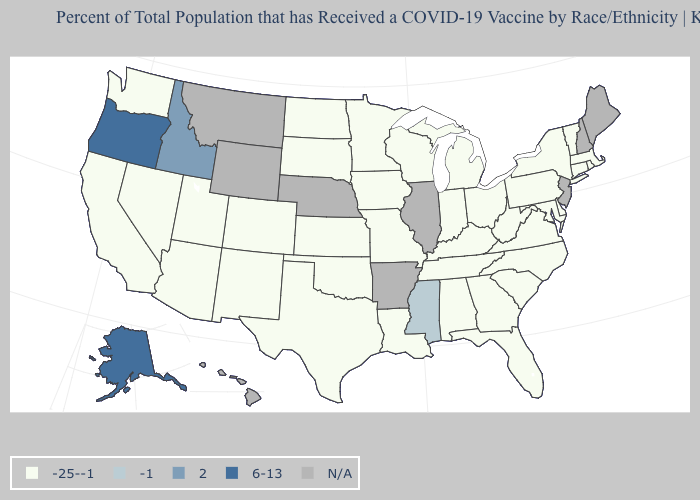Does Alaska have the lowest value in the West?
Keep it brief. No. How many symbols are there in the legend?
Short answer required. 5. What is the value of Nebraska?
Short answer required. N/A. What is the value of Mississippi?
Write a very short answer. -1. Among the states that border Louisiana , does Texas have the highest value?
Short answer required. No. What is the highest value in the USA?
Concise answer only. 6-13. Which states have the highest value in the USA?
Be succinct. Alaska, Oregon. What is the value of Kansas?
Short answer required. -25--1. What is the value of Hawaii?
Keep it brief. N/A. What is the value of Vermont?
Concise answer only. -25--1. Which states hav the highest value in the MidWest?
Quick response, please. Indiana, Iowa, Kansas, Michigan, Minnesota, Missouri, North Dakota, Ohio, South Dakota, Wisconsin. How many symbols are there in the legend?
Give a very brief answer. 5. Name the states that have a value in the range -1?
Give a very brief answer. Mississippi. Which states have the lowest value in the USA?
Concise answer only. Alabama, Arizona, California, Colorado, Connecticut, Delaware, Florida, Georgia, Indiana, Iowa, Kansas, Kentucky, Louisiana, Maryland, Massachusetts, Michigan, Minnesota, Missouri, Nevada, New Mexico, New York, North Carolina, North Dakota, Ohio, Oklahoma, Pennsylvania, Rhode Island, South Carolina, South Dakota, Tennessee, Texas, Utah, Vermont, Virginia, Washington, West Virginia, Wisconsin. What is the lowest value in the USA?
Keep it brief. -25--1. 